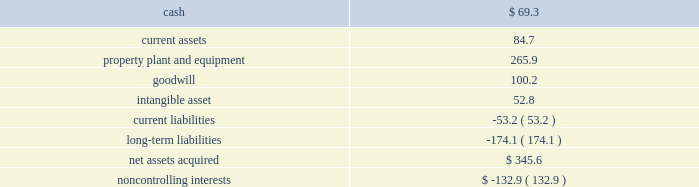Page 45 of 100 ball corporation and subsidiaries notes to consolidated financial statements 3 .
Acquisitions latapack-ball embalagens ltda .
( latapack-ball ) in august 2010 , the company paid $ 46.2 million to acquire an additional 10.1 percent economic interest in its brazilian beverage packaging joint venture , latapack-ball , through a transaction with the joint venture partner , latapack s.a .
This transaction increased the company 2019s overall economic interest in the joint venture to 60.1 percent and expands and strengthens ball 2019s presence in the growing brazilian market .
As a result of the transaction , latapack-ball became a variable interest entity ( vie ) under consolidation accounting guidelines with ball being identified as the primary beneficiary of the vie and consolidating the joint venture .
Latapack-ball operates metal beverage packaging manufacturing plants in tres rios , jacarei and salvador , brazil and has been included in the metal beverage packaging , americas and asia , reporting segment .
In connection with the acquisition , the company recorded a gain of $ 81.8 million on its previously held equity investment in latapack-ball as a result of required purchase accounting .
The table summarizes the final fair values of the latapack-ball assets acquired , liabilities assumed and non- controlling interest recognized , as well as the related investment in latapack s.a. , as of the acquisition date .
The valuation was based on market and income approaches. .
Noncontrolling interests $ ( 132.9 ) the customer relationships were identified as an intangible asset by the company and assigned an estimated life of 13.4 years .
The intangible asset is being amortized on a straight-line basis .
Neuman aluminum ( neuman ) in july 2010 , the company acquired neuman for approximately $ 62 million in cash .
Neuman had sales of approximately $ 128 million in 2009 ( unaudited ) and is the leading north american manufacturer of aluminum slugs used to make extruded aerosol cans , beverage bottles , aluminum collapsible tubes and technical impact extrusions .
Neuman operates two plants , one in the united states and one in canada , which employ approximately 180 people .
The acquisition of neuman is not material to the metal food and household products packaging , americas , segment , in which its results of operations have been included since the acquisition date .
Guangdong jianlibao group co. , ltd ( jianlibao ) in june 2010 , the company acquired jianlibao 2019s 65 percent interest in a joint venture metal beverage can and end plant in sanshui ( foshan ) , prc .
Ball has owned 35 percent of the joint venture plant since 1992 .
Ball acquired the 65 percent interest for $ 86.9 million in cash ( net of cash acquired ) and assumed debt , and also entered into a long-term supply agreement with jianlibao and one of its affiliates .
The company recorded equity earnings of $ 24.1 million , which was composed of equity earnings and a gain realized on the fair value of ball 2019s previous 35 percent equity investment as a result of required purchase accounting .
The purchase accounting was completed during the third quarter of 2010 .
The acquisition of the remaining interest is not material to the metal beverage packaging , americas and asia , segment. .
What percentage of net assets acquired was goodwill? 
Computations: (100.2 / 345.6)
Answer: 0.28993. 